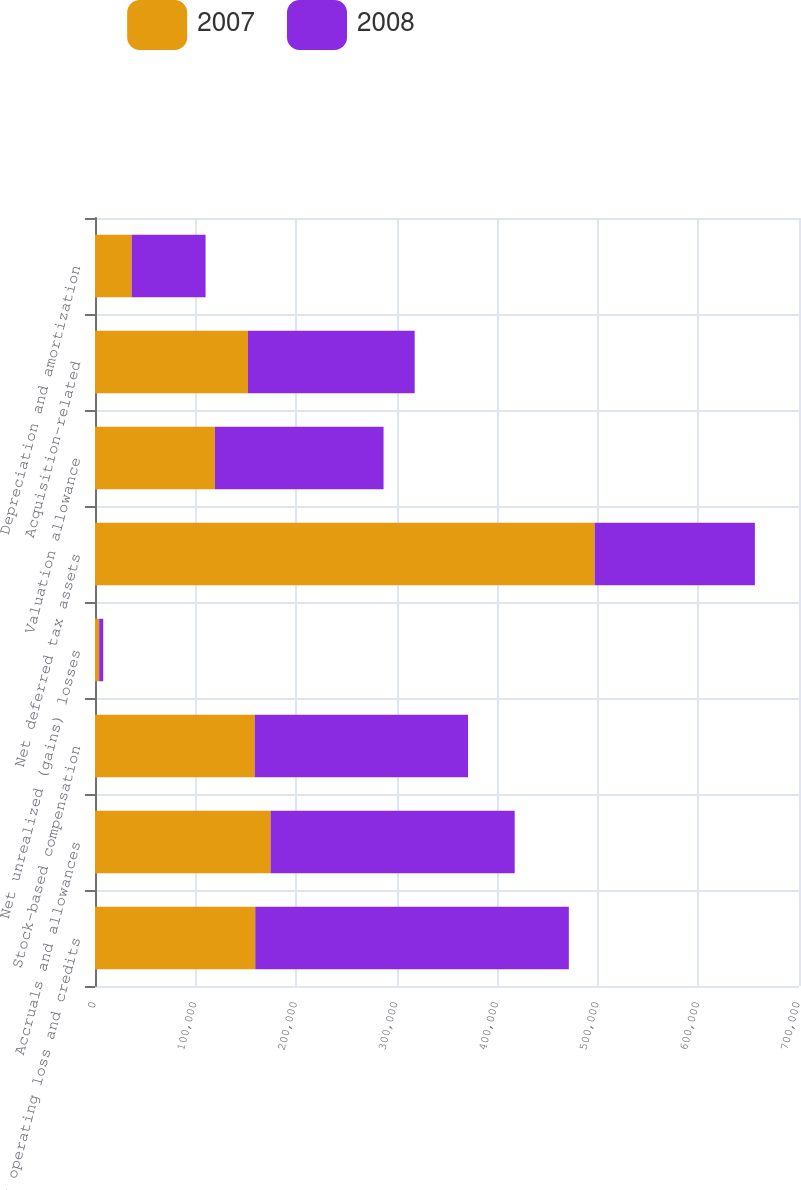Convert chart to OTSL. <chart><loc_0><loc_0><loc_500><loc_500><stacked_bar_chart><ecel><fcel>Net operating loss and credits<fcel>Accruals and allowances<fcel>Stock-based compensation<fcel>Net unrealized (gains) losses<fcel>Net deferred tax assets<fcel>Valuation allowance<fcel>Acquisition-related<fcel>Depreciation and amortization<nl><fcel>2007<fcel>159333<fcel>174552<fcel>158767<fcel>4145<fcel>496797<fcel>119153<fcel>152068<fcel>36462<nl><fcel>2008<fcel>311807<fcel>242763<fcel>212147<fcel>4052<fcel>159333<fcel>167767<fcel>165793<fcel>73477<nl></chart> 